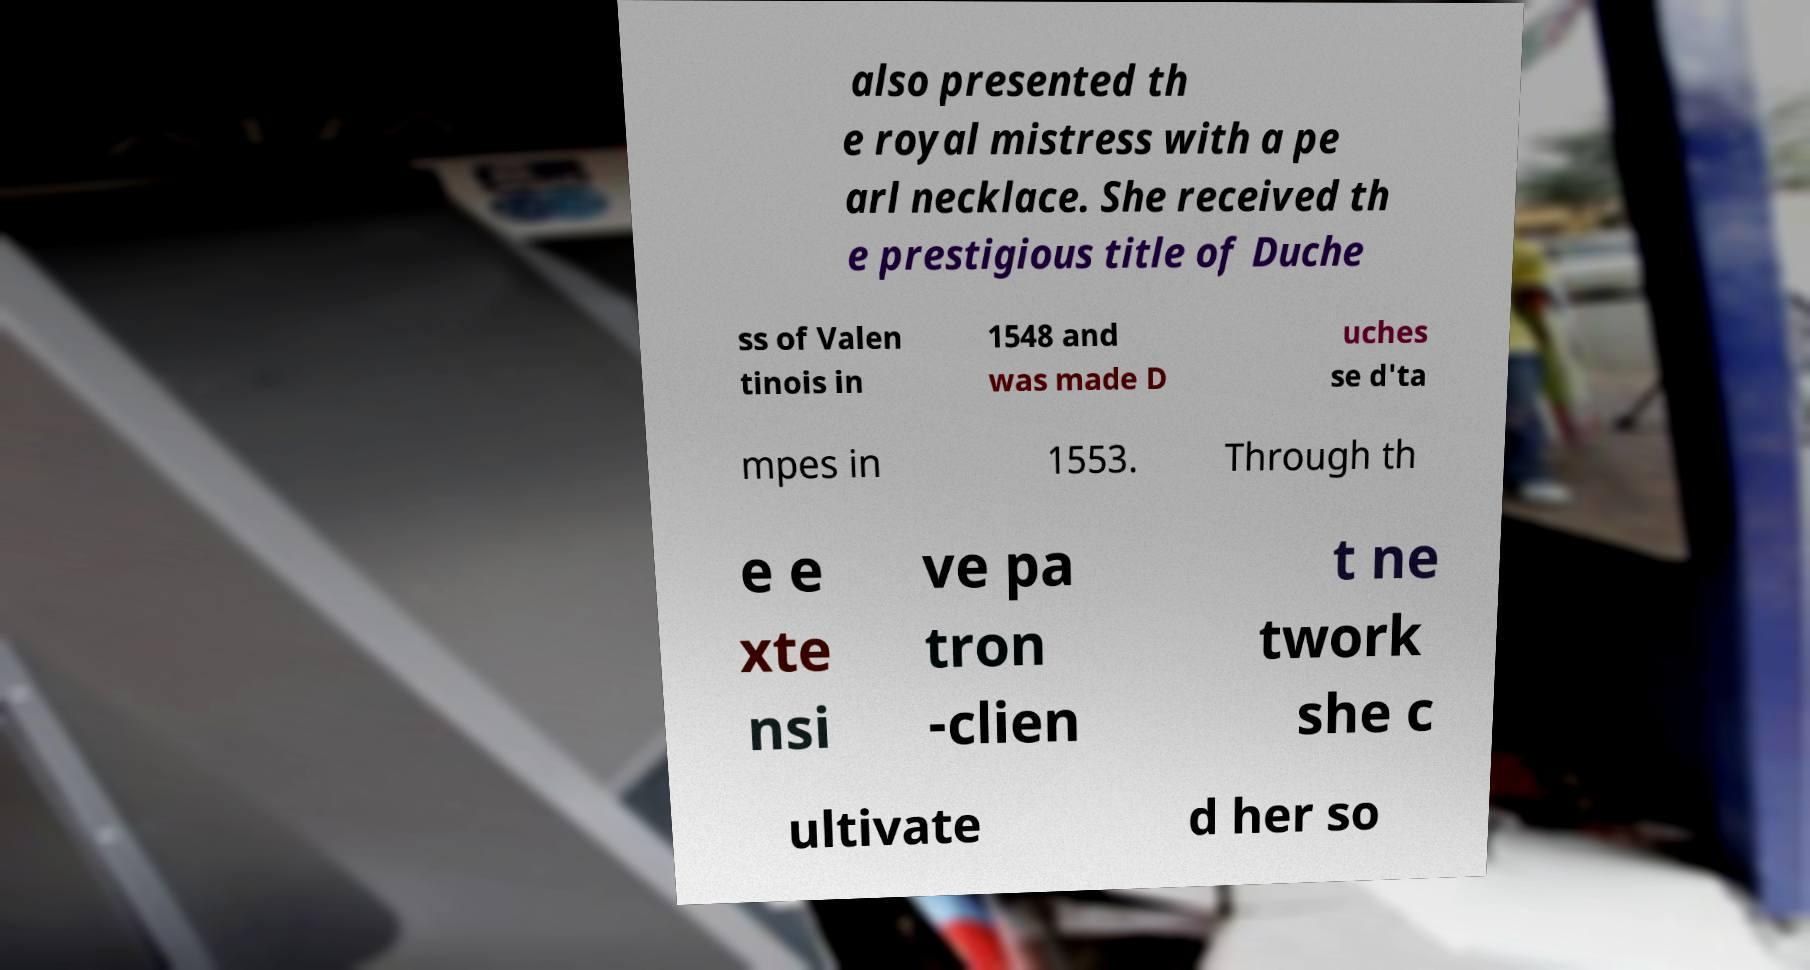What messages or text are displayed in this image? I need them in a readable, typed format. also presented th e royal mistress with a pe arl necklace. She received th e prestigious title of Duche ss of Valen tinois in 1548 and was made D uches se d'ta mpes in 1553. Through th e e xte nsi ve pa tron -clien t ne twork she c ultivate d her so 